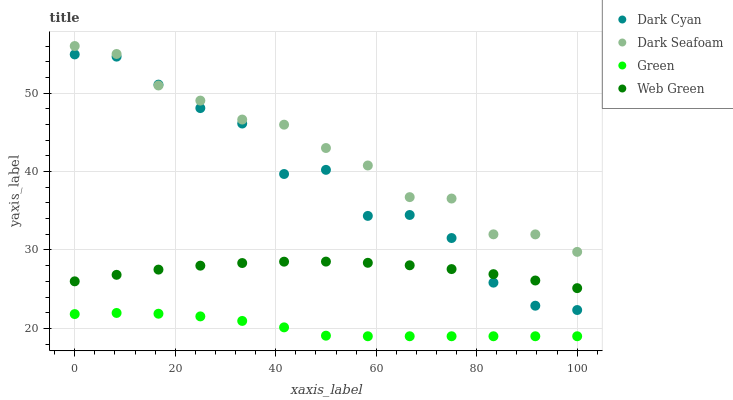Does Green have the minimum area under the curve?
Answer yes or no. Yes. Does Dark Seafoam have the maximum area under the curve?
Answer yes or no. Yes. Does Dark Seafoam have the minimum area under the curve?
Answer yes or no. No. Does Green have the maximum area under the curve?
Answer yes or no. No. Is Web Green the smoothest?
Answer yes or no. Yes. Is Dark Cyan the roughest?
Answer yes or no. Yes. Is Dark Seafoam the smoothest?
Answer yes or no. No. Is Dark Seafoam the roughest?
Answer yes or no. No. Does Green have the lowest value?
Answer yes or no. Yes. Does Dark Seafoam have the lowest value?
Answer yes or no. No. Does Dark Seafoam have the highest value?
Answer yes or no. Yes. Does Green have the highest value?
Answer yes or no. No. Is Green less than Dark Cyan?
Answer yes or no. Yes. Is Dark Seafoam greater than Web Green?
Answer yes or no. Yes. Does Dark Seafoam intersect Dark Cyan?
Answer yes or no. Yes. Is Dark Seafoam less than Dark Cyan?
Answer yes or no. No. Is Dark Seafoam greater than Dark Cyan?
Answer yes or no. No. Does Green intersect Dark Cyan?
Answer yes or no. No. 